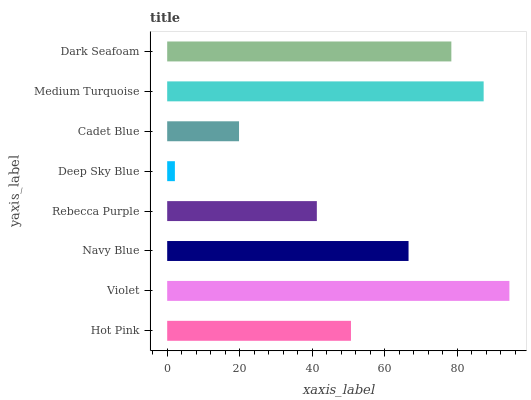Is Deep Sky Blue the minimum?
Answer yes or no. Yes. Is Violet the maximum?
Answer yes or no. Yes. Is Navy Blue the minimum?
Answer yes or no. No. Is Navy Blue the maximum?
Answer yes or no. No. Is Violet greater than Navy Blue?
Answer yes or no. Yes. Is Navy Blue less than Violet?
Answer yes or no. Yes. Is Navy Blue greater than Violet?
Answer yes or no. No. Is Violet less than Navy Blue?
Answer yes or no. No. Is Navy Blue the high median?
Answer yes or no. Yes. Is Hot Pink the low median?
Answer yes or no. Yes. Is Cadet Blue the high median?
Answer yes or no. No. Is Deep Sky Blue the low median?
Answer yes or no. No. 